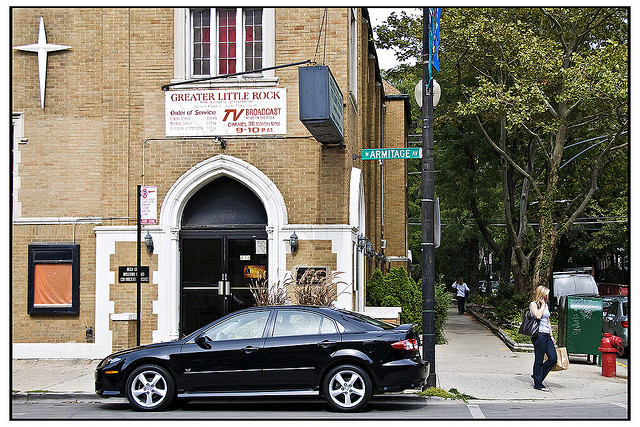Please extract the text content from this image. GREATER LITTLE ROCK TV BROADCAST ARMITAGE 10 